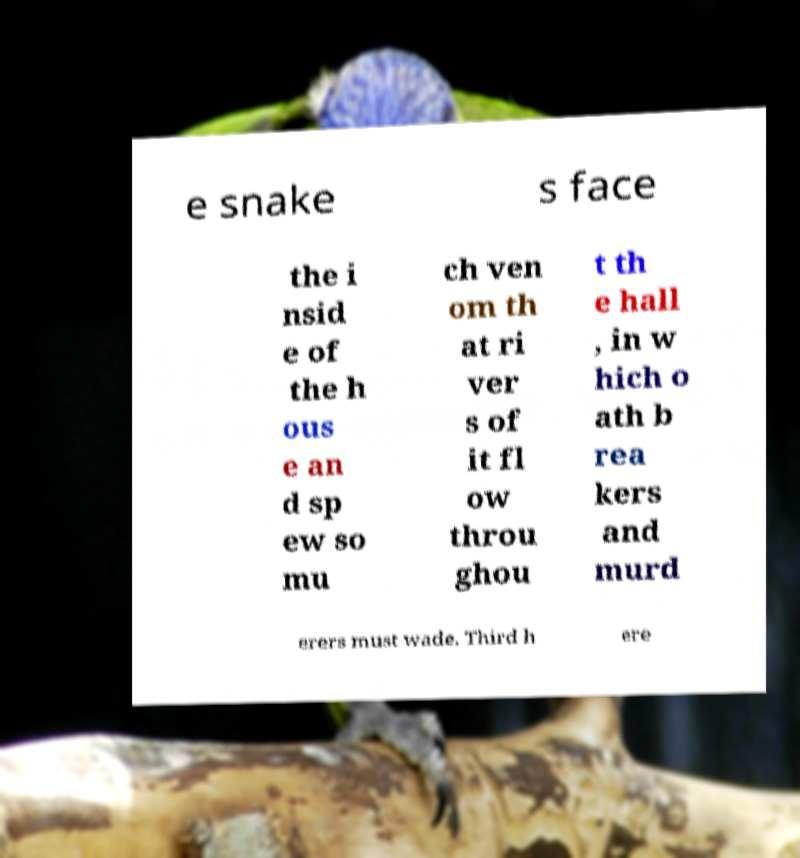Can you read and provide the text displayed in the image?This photo seems to have some interesting text. Can you extract and type it out for me? e snake s face the i nsid e of the h ous e an d sp ew so mu ch ven om th at ri ver s of it fl ow throu ghou t th e hall , in w hich o ath b rea kers and murd erers must wade. Third h ere 